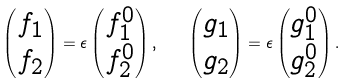<formula> <loc_0><loc_0><loc_500><loc_500>\begin{pmatrix} f _ { 1 } \\ f _ { 2 } \end{pmatrix} = \epsilon \begin{pmatrix} f _ { 1 } ^ { 0 } \\ f _ { 2 } ^ { 0 } \end{pmatrix} , \quad \begin{pmatrix} g _ { 1 } \\ g _ { 2 } \end{pmatrix} = \epsilon \begin{pmatrix} g _ { 1 } ^ { 0 } \\ g _ { 2 } ^ { 0 } \end{pmatrix} .</formula> 